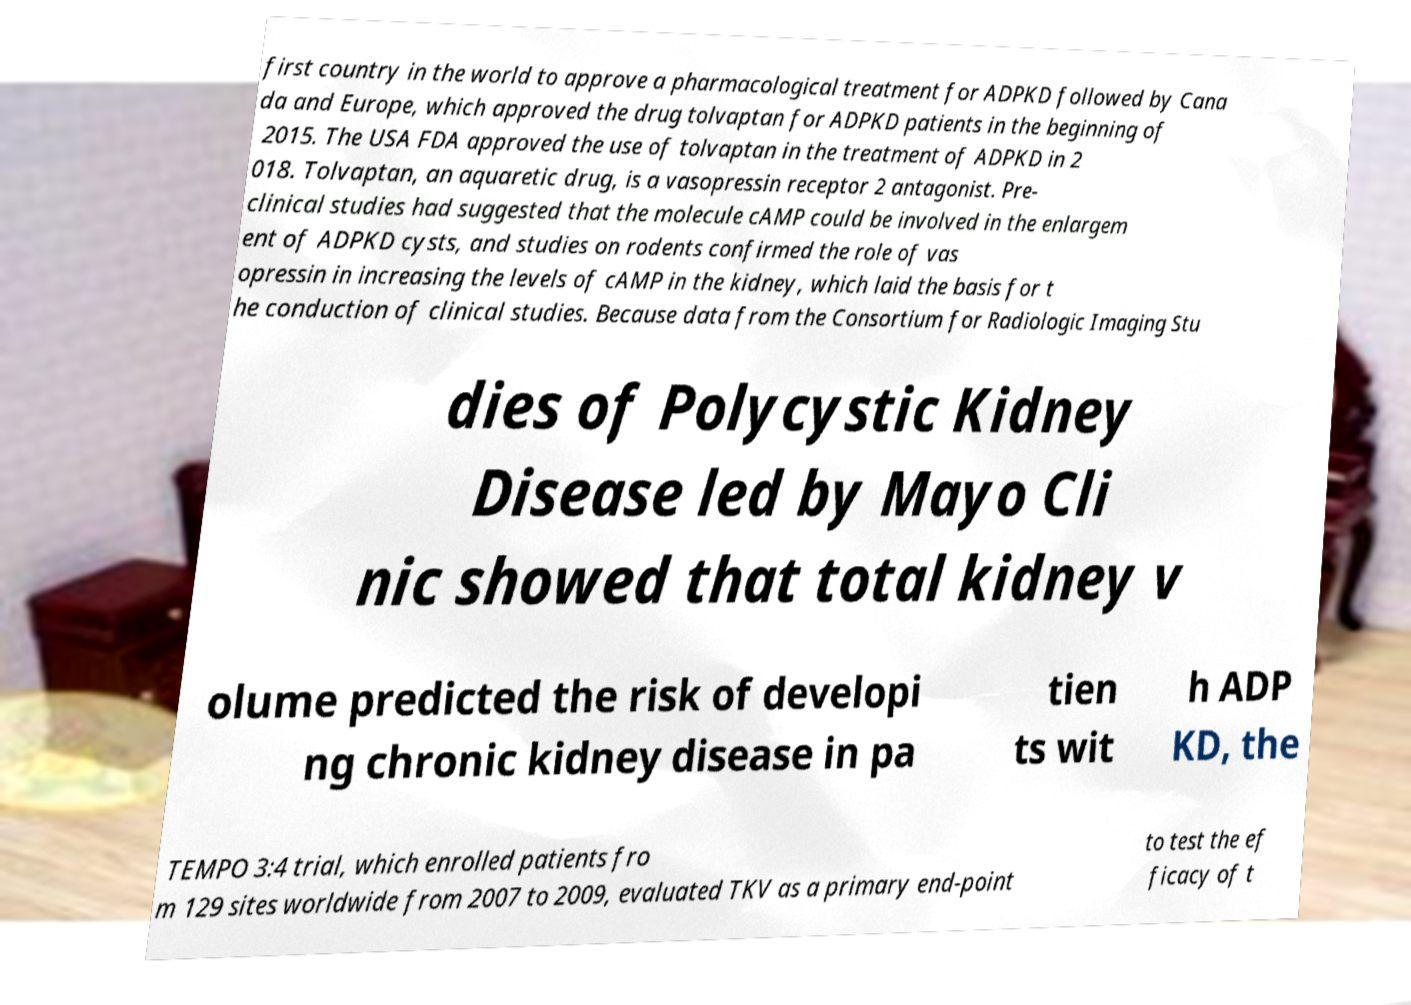I need the written content from this picture converted into text. Can you do that? first country in the world to approve a pharmacological treatment for ADPKD followed by Cana da and Europe, which approved the drug tolvaptan for ADPKD patients in the beginning of 2015. The USA FDA approved the use of tolvaptan in the treatment of ADPKD in 2 018. Tolvaptan, an aquaretic drug, is a vasopressin receptor 2 antagonist. Pre- clinical studies had suggested that the molecule cAMP could be involved in the enlargem ent of ADPKD cysts, and studies on rodents confirmed the role of vas opressin in increasing the levels of cAMP in the kidney, which laid the basis for t he conduction of clinical studies. Because data from the Consortium for Radiologic Imaging Stu dies of Polycystic Kidney Disease led by Mayo Cli nic showed that total kidney v olume predicted the risk of developi ng chronic kidney disease in pa tien ts wit h ADP KD, the TEMPO 3:4 trial, which enrolled patients fro m 129 sites worldwide from 2007 to 2009, evaluated TKV as a primary end-point to test the ef ficacy of t 